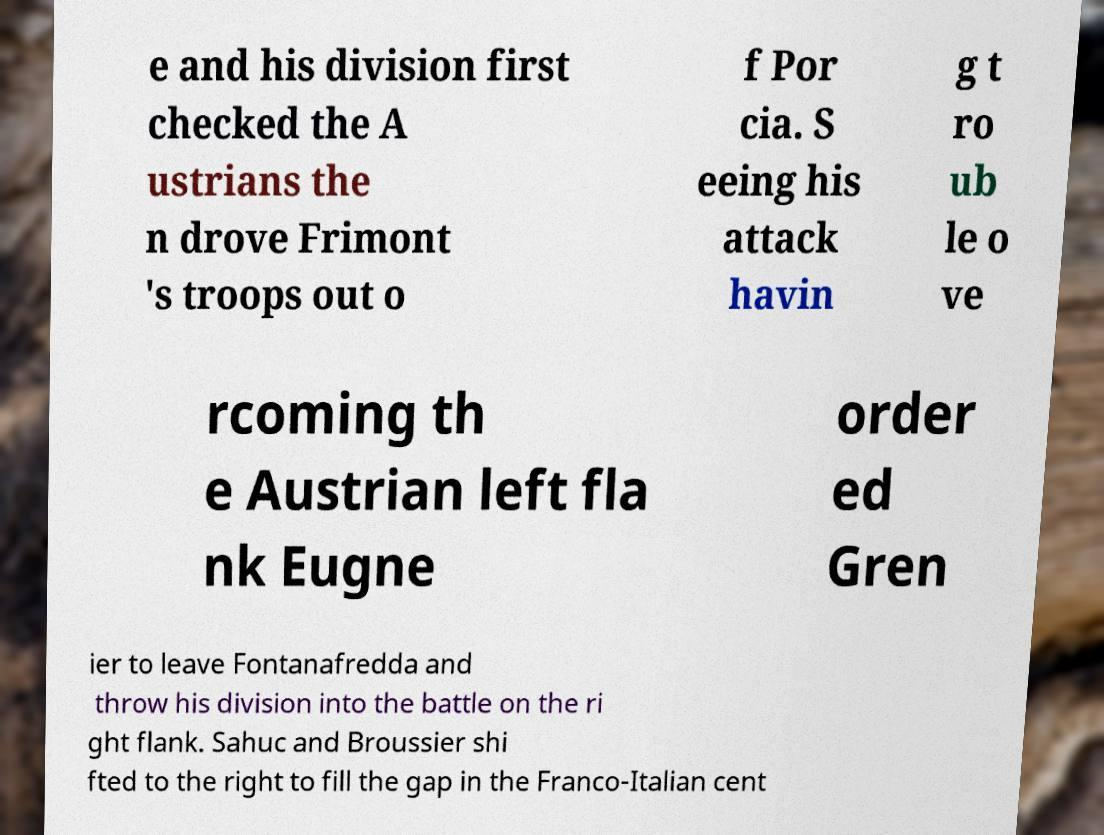Please identify and transcribe the text found in this image. e and his division first checked the A ustrians the n drove Frimont 's troops out o f Por cia. S eeing his attack havin g t ro ub le o ve rcoming th e Austrian left fla nk Eugne order ed Gren ier to leave Fontanafredda and throw his division into the battle on the ri ght flank. Sahuc and Broussier shi fted to the right to fill the gap in the Franco-Italian cent 